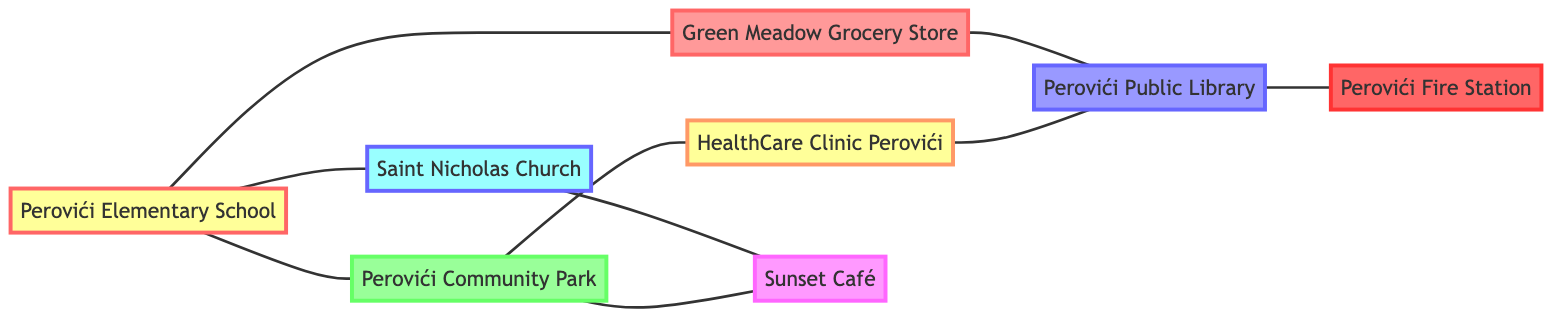What locations are directly connected to Perovići Elementary School? The diagram shows that Perovići Elementary School is connected to three locations: Saint Nicholas Church, Perovići Community Park, and Green Meadow Grocery Store. We can find these locations by looking for the edges that emanate from the node representing Perovići Elementary School.
Answer: Saint Nicholas Church, Perovići Community Park, Green Meadow Grocery Store How many locations are included in the diagram? To determine the total number of locations, we count the nodes in the diagram. There are eight distinct locations listed: Perovići Elementary School, Saint Nicholas Church, Perovići Community Park, Green Meadow Grocery Store, HealthCare Clinic Perovići, Perovići Public Library, Sunset Café, and Perovići Fire Station.
Answer: 8 What is the connection between Saint Nicholas Church and Sunset Café? The diagram indicates there is a direct connection between these two locations, represented by an edge connecting Saint Nicholas Church to Sunset Café. This can be seen by checking the connections associated with each location.
Answer: Direct connection Which location is only directly connected to one other location? By examining the connections in the diagram, we can identify that Perovići Fire Station is only directly connected to Perovići Public Library, meaning it has just one edge linking it to another location.
Answer: Perovići Fire Station How many total connections are there in the diagram? To find the total number of connections (edges), we need to count each unique connection in the diagram. After tallying the direct connections between locations, we find a total of 8 distinct edges.
Answer: 8 Which location has connections to both Perovići Community Park and Green Meadow Grocery Store? By analyzing the connections of each location, we can see that Perovići Public Library connects to HealthCare Clinic Perovići and Green Meadow Grocery Store, while Perovići Community Park connects to both Perovići Elementary School and HealthCare Clinic Perovići, indicating these connections. However, Perovići Public Library is the only location that connects to both of them through separate paths.
Answer: Perovići Public Library Is there any location that connects to both a grocery store and a café? Looking at the connections in the diagram, we see that Perovići Community Park connects to Sunset Café and is also connected to Green Meadow Grocery Store, fulfilling the requirement of connecting to both a grocery store and a café.
Answer: Perovići Community Park 